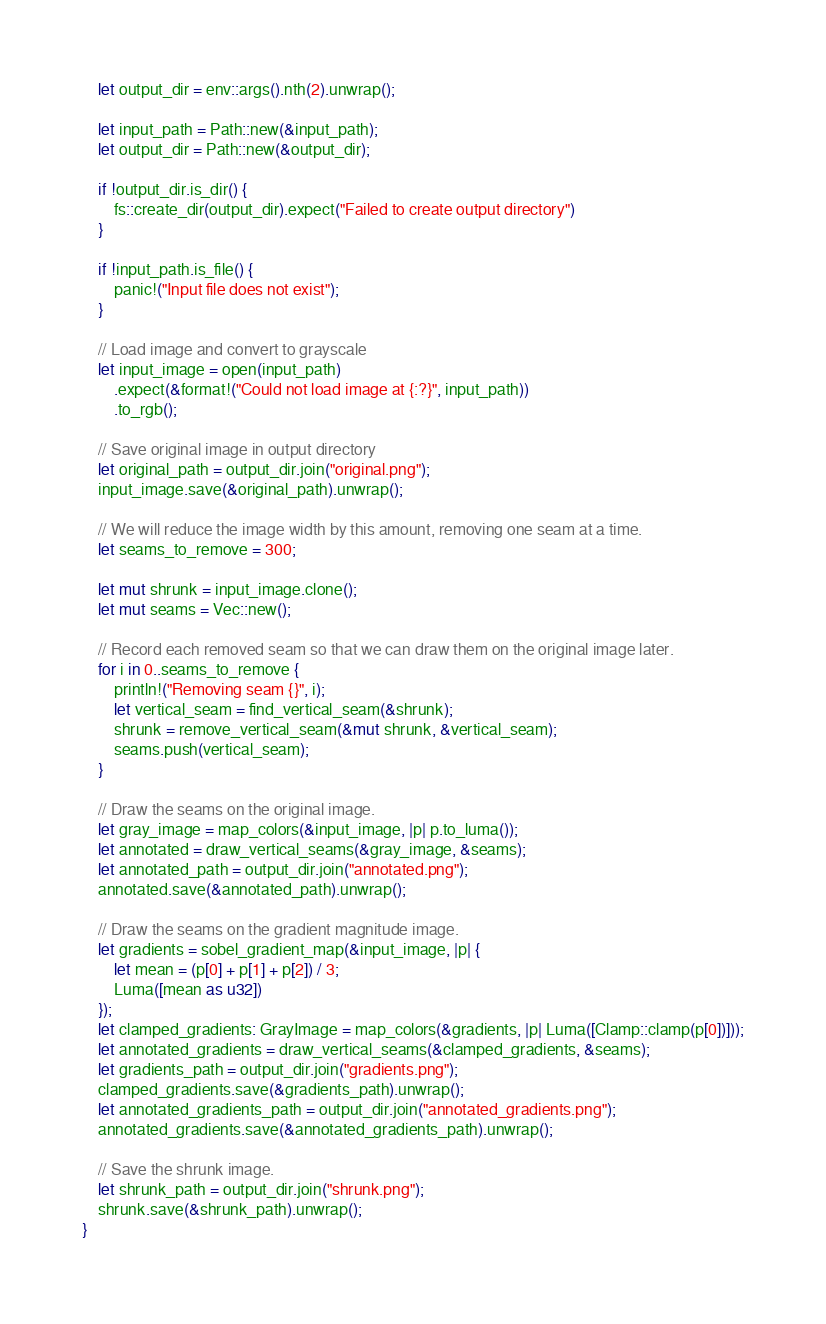<code> <loc_0><loc_0><loc_500><loc_500><_Rust_>    let output_dir = env::args().nth(2).unwrap();

    let input_path = Path::new(&input_path);
    let output_dir = Path::new(&output_dir);

    if !output_dir.is_dir() {
        fs::create_dir(output_dir).expect("Failed to create output directory")
    }

    if !input_path.is_file() {
        panic!("Input file does not exist");
    }

    // Load image and convert to grayscale
    let input_image = open(input_path)
        .expect(&format!("Could not load image at {:?}", input_path))
        .to_rgb();

    // Save original image in output directory
    let original_path = output_dir.join("original.png");
    input_image.save(&original_path).unwrap();

    // We will reduce the image width by this amount, removing one seam at a time.
    let seams_to_remove = 300;

    let mut shrunk = input_image.clone();
    let mut seams = Vec::new();

    // Record each removed seam so that we can draw them on the original image later.
    for i in 0..seams_to_remove {
        println!("Removing seam {}", i);
        let vertical_seam = find_vertical_seam(&shrunk);
        shrunk = remove_vertical_seam(&mut shrunk, &vertical_seam);
        seams.push(vertical_seam);
    }

    // Draw the seams on the original image.
    let gray_image = map_colors(&input_image, |p| p.to_luma());
    let annotated = draw_vertical_seams(&gray_image, &seams);
    let annotated_path = output_dir.join("annotated.png");
    annotated.save(&annotated_path).unwrap();

    // Draw the seams on the gradient magnitude image.
    let gradients = sobel_gradient_map(&input_image, |p| {
        let mean = (p[0] + p[1] + p[2]) / 3;
        Luma([mean as u32])
    });
    let clamped_gradients: GrayImage = map_colors(&gradients, |p| Luma([Clamp::clamp(p[0])]));
    let annotated_gradients = draw_vertical_seams(&clamped_gradients, &seams);
    let gradients_path = output_dir.join("gradients.png");
    clamped_gradients.save(&gradients_path).unwrap();
    let annotated_gradients_path = output_dir.join("annotated_gradients.png");
    annotated_gradients.save(&annotated_gradients_path).unwrap();

    // Save the shrunk image.
    let shrunk_path = output_dir.join("shrunk.png");
    shrunk.save(&shrunk_path).unwrap();
}
</code> 